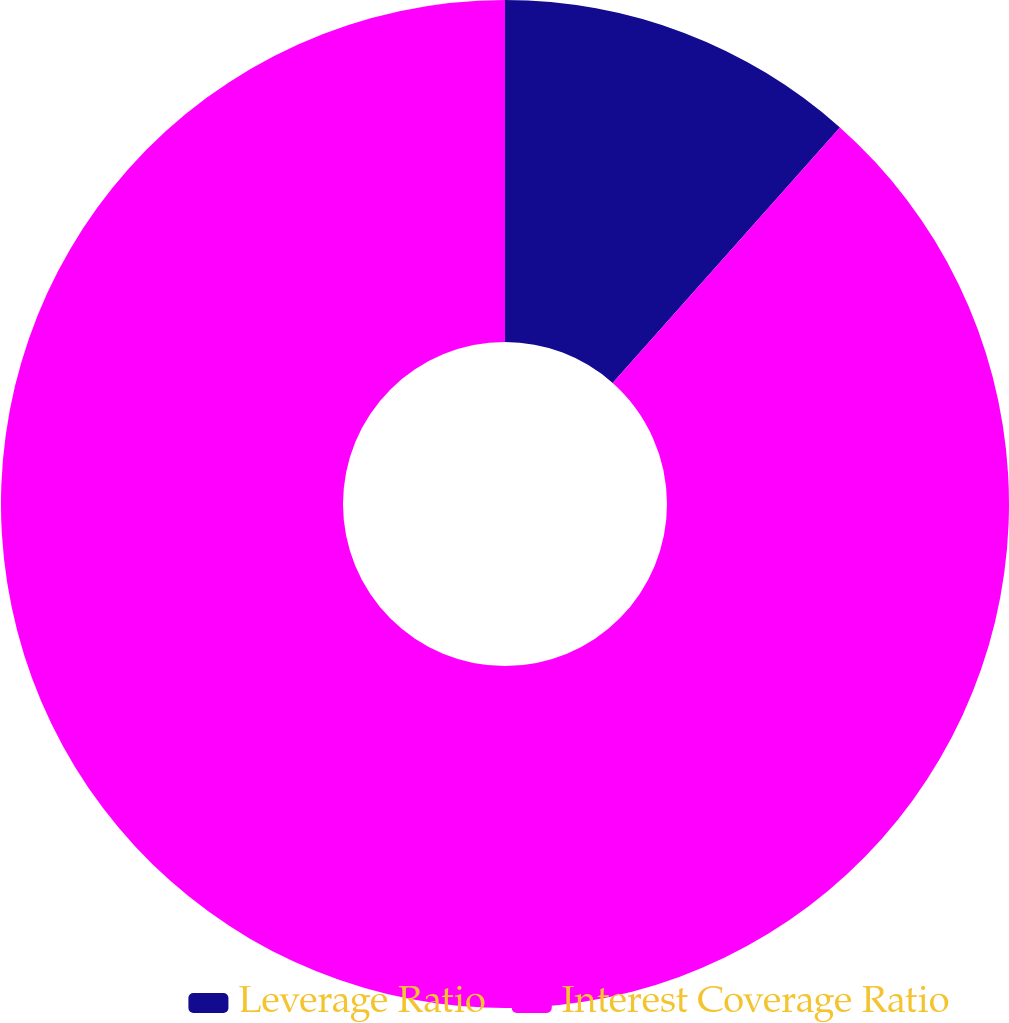Convert chart. <chart><loc_0><loc_0><loc_500><loc_500><pie_chart><fcel>Leverage Ratio<fcel>Interest Coverage Ratio<nl><fcel>11.57%<fcel>88.43%<nl></chart> 